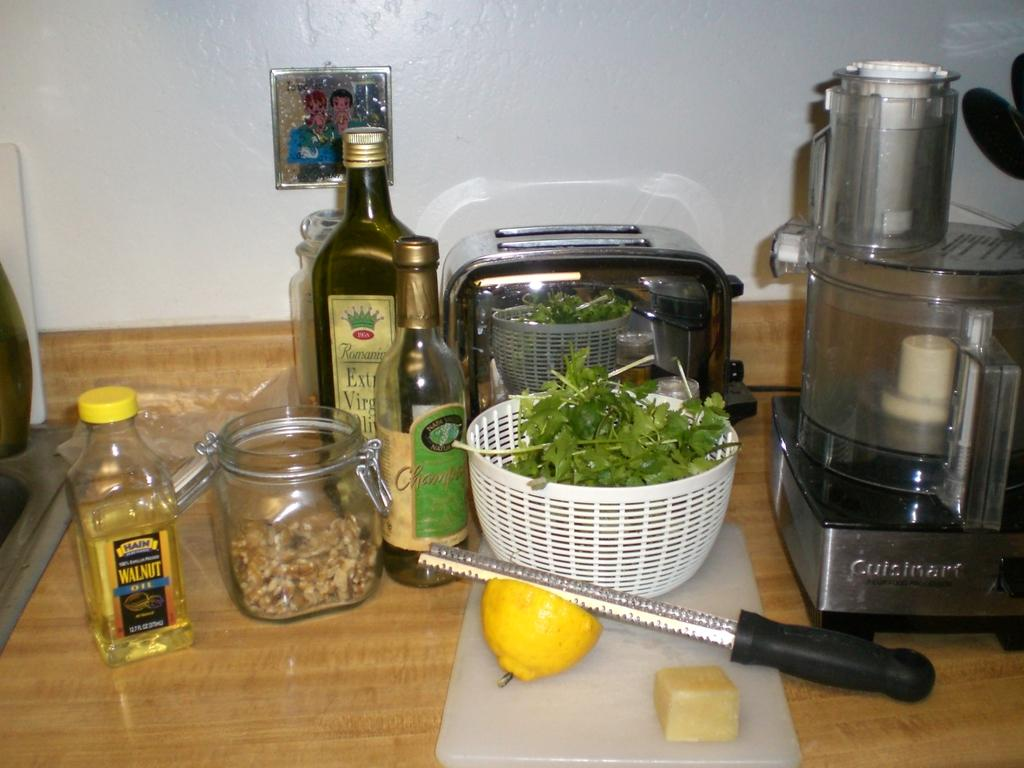<image>
Relay a brief, clear account of the picture shown. Supplies to make a salad including Walnut oil sit on a kitchen counter. 